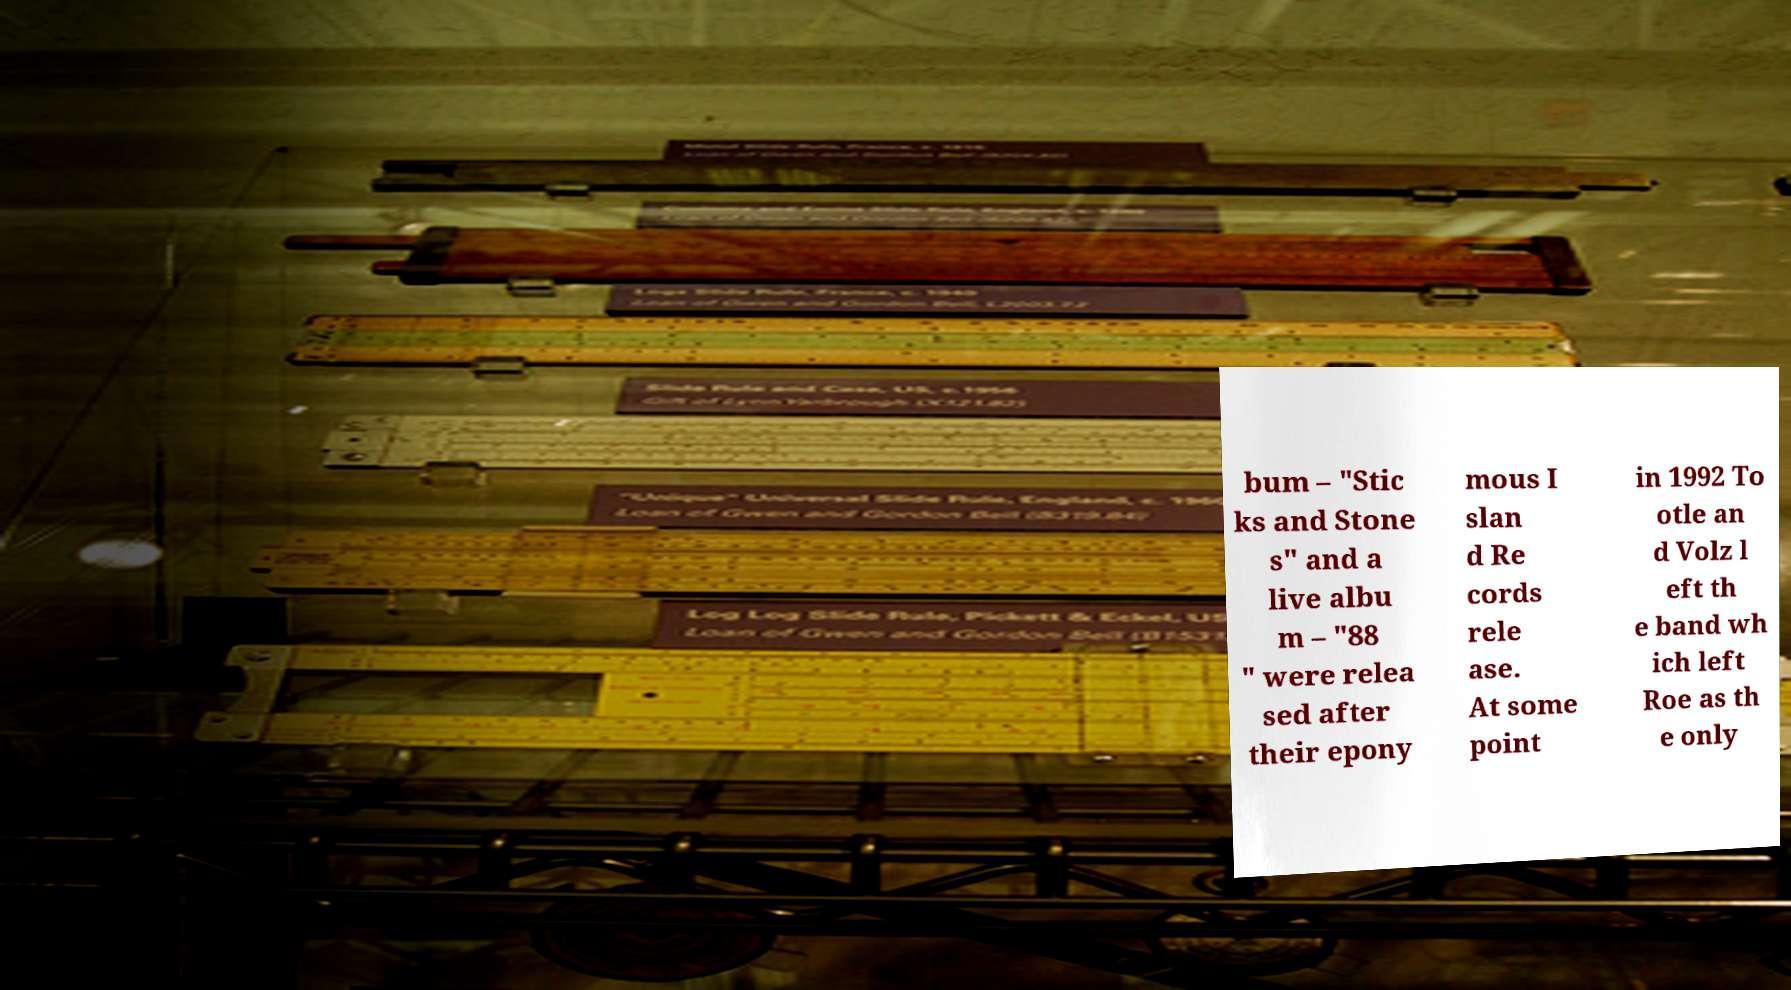For documentation purposes, I need the text within this image transcribed. Could you provide that? bum – "Stic ks and Stone s" and a live albu m – "88 " were relea sed after their epony mous I slan d Re cords rele ase. At some point in 1992 To otle an d Volz l eft th e band wh ich left Roe as th e only 